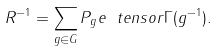<formula> <loc_0><loc_0><loc_500><loc_500>R ^ { - 1 } = \sum _ { g \in G } P _ { g } e \ t e n s o r \Gamma ( g ^ { - 1 } ) .</formula> 